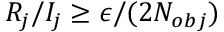<formula> <loc_0><loc_0><loc_500><loc_500>R _ { j } / I _ { j } \geq \epsilon / ( 2 N _ { o b j } )</formula> 